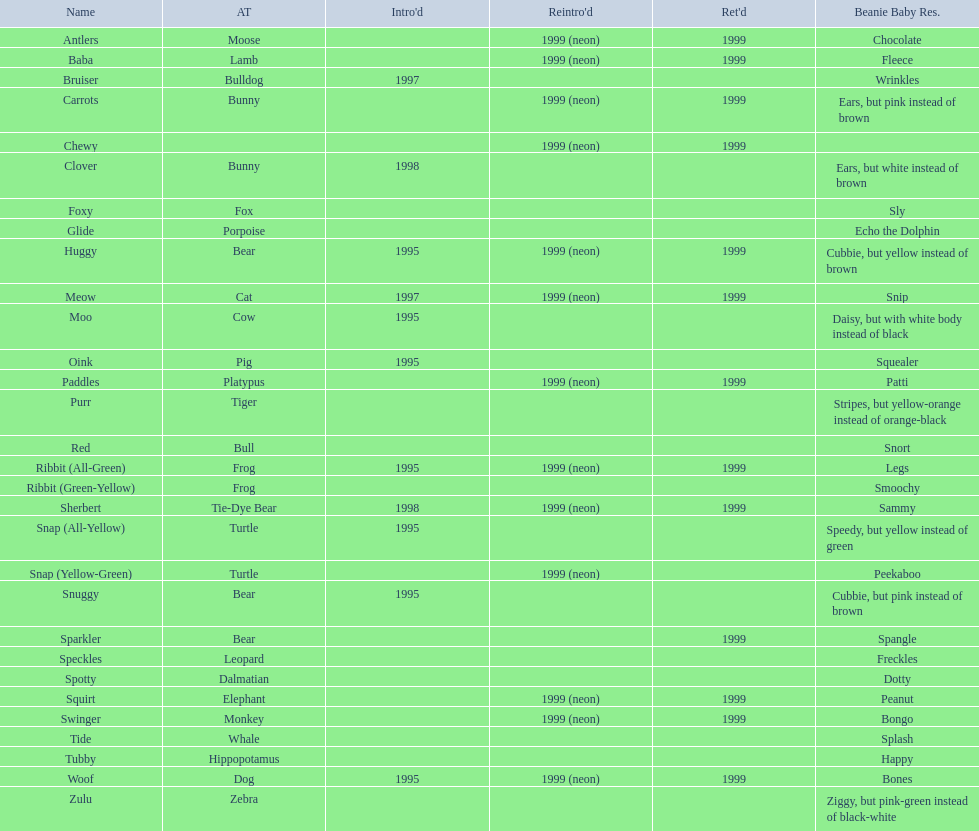What are all the different names of the pillow pals? Antlers, Baba, Bruiser, Carrots, Chewy, Clover, Foxy, Glide, Huggy, Meow, Moo, Oink, Paddles, Purr, Red, Ribbit (All-Green), Ribbit (Green-Yellow), Sherbert, Snap (All-Yellow), Snap (Yellow-Green), Snuggy, Sparkler, Speckles, Spotty, Squirt, Swinger, Tide, Tubby, Woof, Zulu. Which of these are a dalmatian? Spotty. 